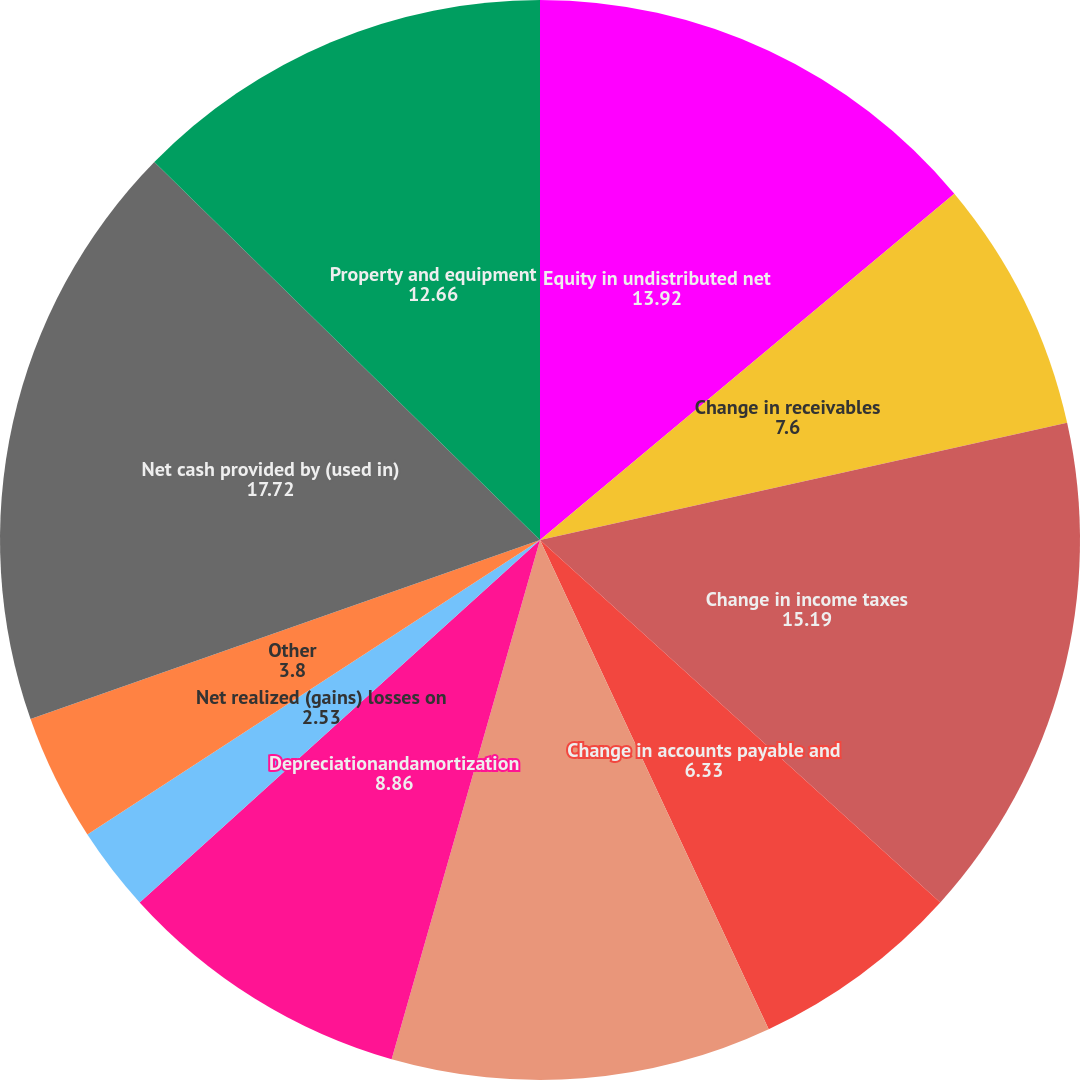Convert chart. <chart><loc_0><loc_0><loc_500><loc_500><pie_chart><fcel>Equity in undistributed net<fcel>Change in receivables<fcel>Change in income taxes<fcel>Change in accounts payable and<fcel>Change in trading portfolio<fcel>Depreciationandamortization<fcel>Net realized (gains) losses on<fcel>Other<fcel>Net cash provided by (used in)<fcel>Property and equipment<nl><fcel>13.92%<fcel>7.6%<fcel>15.19%<fcel>6.33%<fcel>11.39%<fcel>8.86%<fcel>2.53%<fcel>3.8%<fcel>17.72%<fcel>12.66%<nl></chart> 